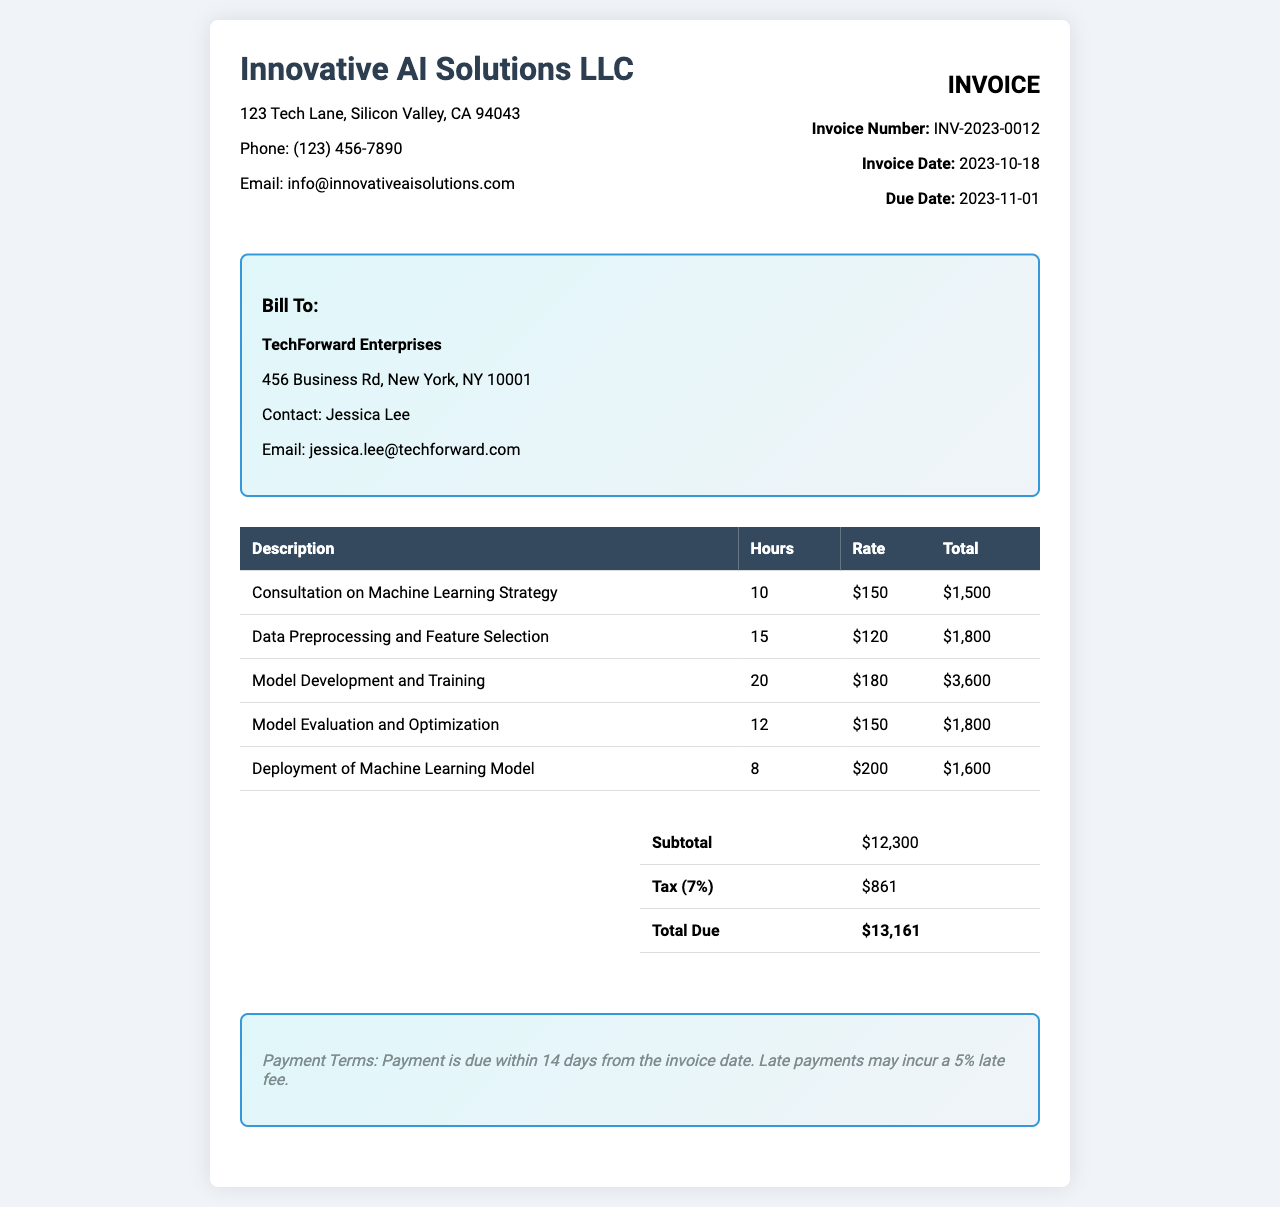What is the total due? The total due is indicated at the bottom of the invoice, which includes the subtotal and tax.
Answer: $13,161 Who is the client? The client is named in the "Bill To" section of the invoice.
Answer: TechForward Enterprises What is the invoice date? The invoice date is clearly stated in the invoice information section.
Answer: 2023-10-18 How many hours were spent on Model Development and Training? The hours for Model Development and Training are listed in the corresponding row of the service description table.
Answer: 20 What is the tax rate applied? The tax rate is mentioned in the summary section of the invoice.
Answer: 7% How much was charged for Data Preprocessing and Feature Selection? The total amount charged for Data Preprocessing and Feature Selection is found in the table of services.
Answer: $1,800 What is the due date for the invoice? The due date is specified in the invoice information section.
Answer: 2023-11-01 What payment terms are described? The payment terms are outlined at the bottom of the invoice, specifying the timeframe for payment.
Answer: Payment is due within 14 days from the invoice date What is the subtotal before tax? The subtotal is provided in the summary section before the tax calculations.
Answer: $12,300 